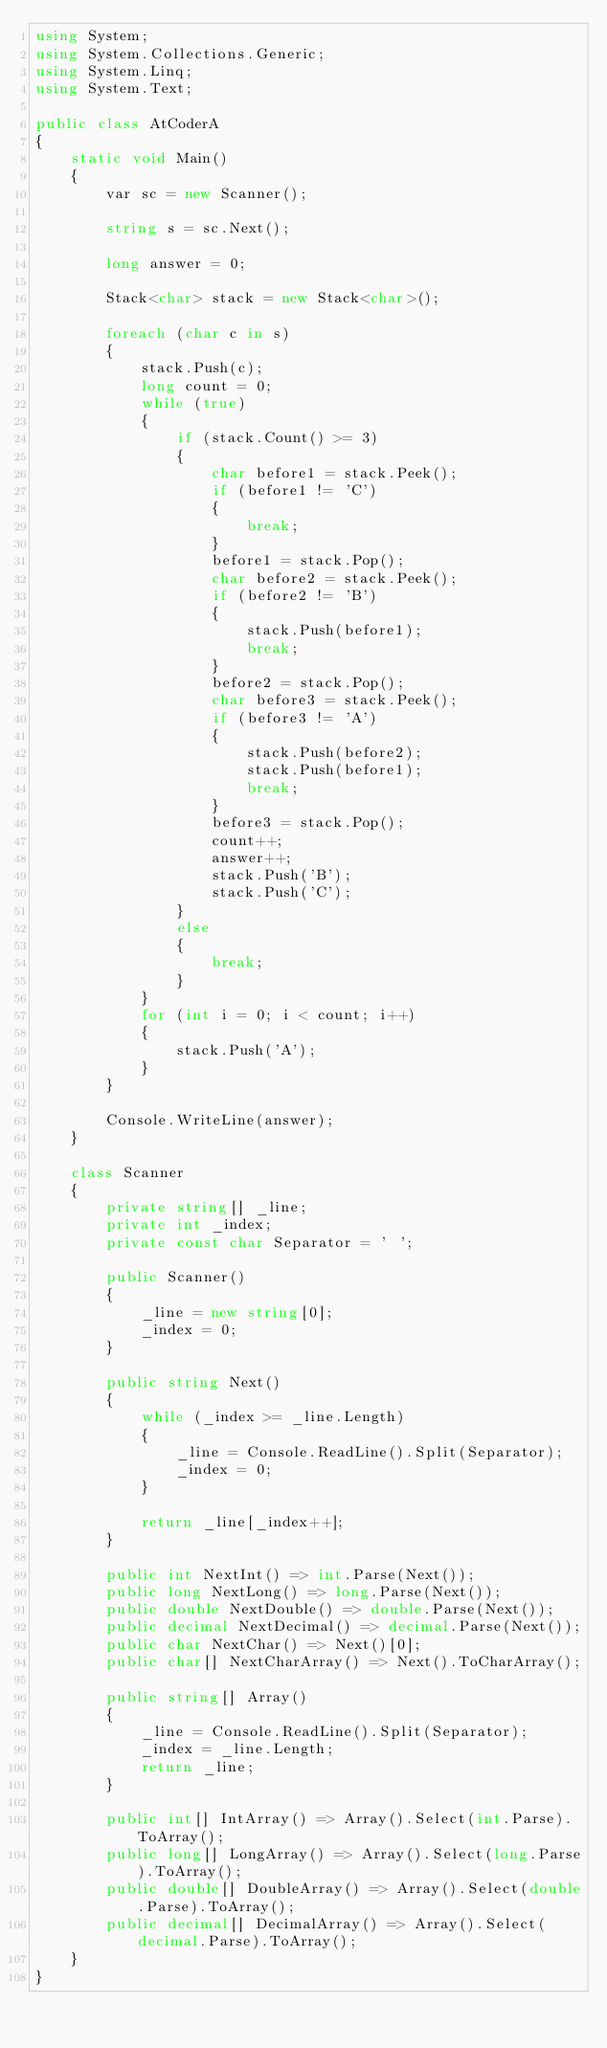<code> <loc_0><loc_0><loc_500><loc_500><_C#_>using System;
using System.Collections.Generic;
using System.Linq;
using System.Text;

public class AtCoderA
{
    static void Main()
    {
        var sc = new Scanner();

        string s = sc.Next();

        long answer = 0;

        Stack<char> stack = new Stack<char>();

        foreach (char c in s)
        {
            stack.Push(c);
            long count = 0;
            while (true)
            {
                if (stack.Count() >= 3)
                {
                    char before1 = stack.Peek();
                    if (before1 != 'C')
                    {
                        break;
                    }
                    before1 = stack.Pop();
                    char before2 = stack.Peek();
                    if (before2 != 'B')
                    {
                        stack.Push(before1);
                        break;
                    }
                    before2 = stack.Pop();
                    char before3 = stack.Peek();
                    if (before3 != 'A')
                    {
                        stack.Push(before2);
                        stack.Push(before1);
                        break;
                    }
                    before3 = stack.Pop();
                    count++;
                    answer++;
                    stack.Push('B');
                    stack.Push('C');
                }
                else
                {
                    break;
                }
            }
            for (int i = 0; i < count; i++)
            {
                stack.Push('A');
            }
        }

        Console.WriteLine(answer);
    }

    class Scanner
    {
        private string[] _line;
        private int _index;
        private const char Separator = ' ';

        public Scanner()
        {
            _line = new string[0];
            _index = 0;
        }

        public string Next()
        {
            while (_index >= _line.Length)
            {
                _line = Console.ReadLine().Split(Separator);
                _index = 0;
            }

            return _line[_index++];
        }

        public int NextInt() => int.Parse(Next());
        public long NextLong() => long.Parse(Next());
        public double NextDouble() => double.Parse(Next());
        public decimal NextDecimal() => decimal.Parse(Next());
        public char NextChar() => Next()[0];
        public char[] NextCharArray() => Next().ToCharArray();

        public string[] Array()
        {
            _line = Console.ReadLine().Split(Separator);
            _index = _line.Length;
            return _line;
        }

        public int[] IntArray() => Array().Select(int.Parse).ToArray();
        public long[] LongArray() => Array().Select(long.Parse).ToArray();
        public double[] DoubleArray() => Array().Select(double.Parse).ToArray();
        public decimal[] DecimalArray() => Array().Select(decimal.Parse).ToArray();
    }
}
</code> 